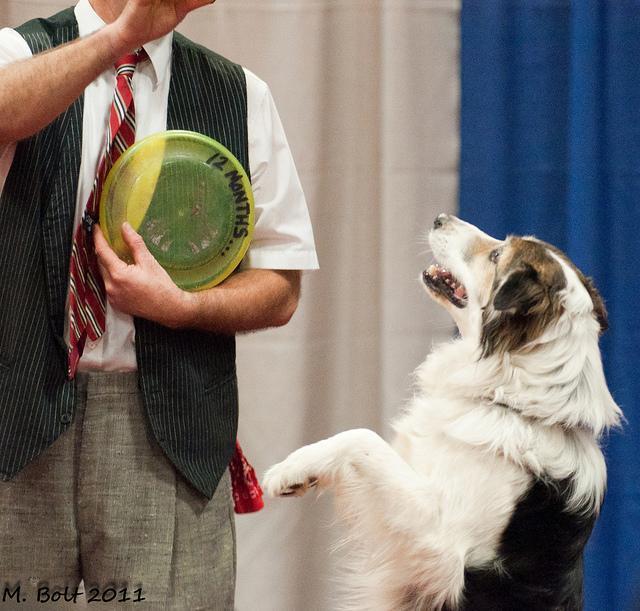How many police cars are visible?
Give a very brief answer. 0. 